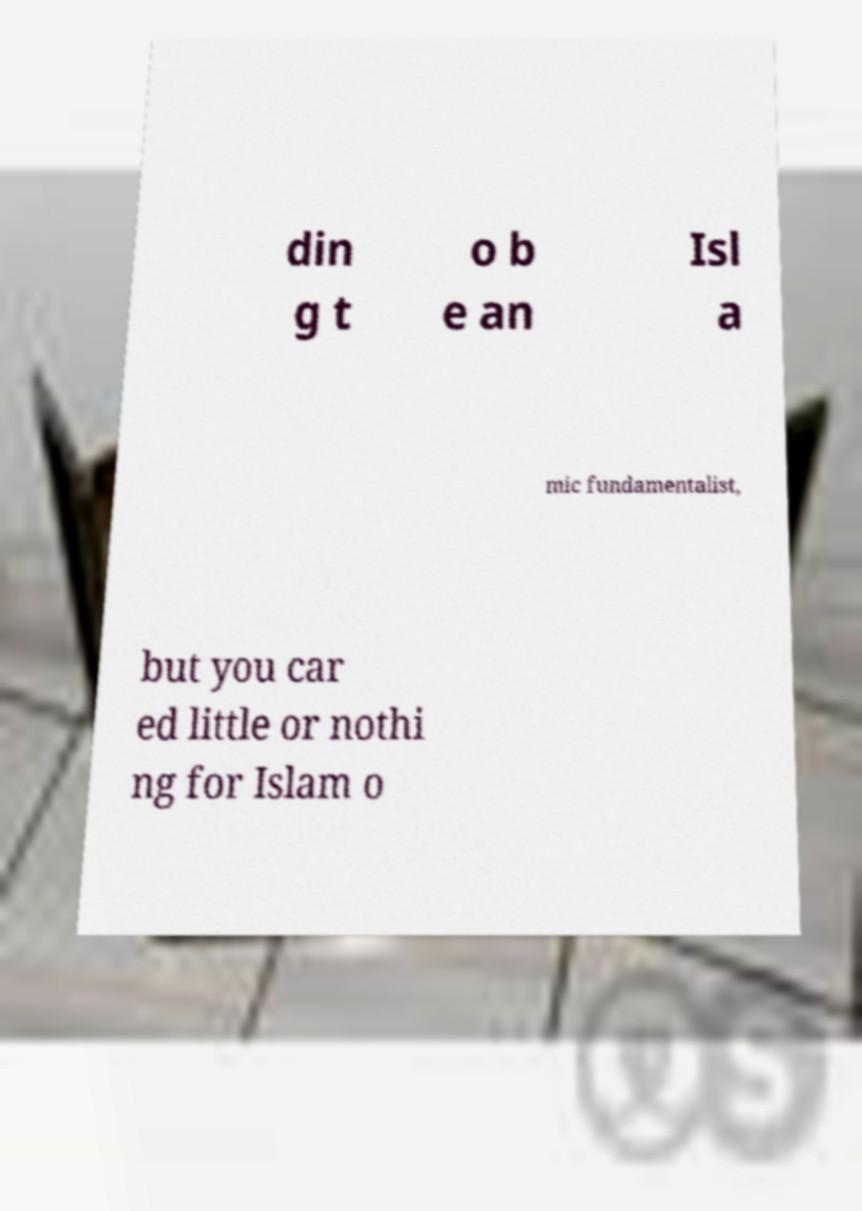I need the written content from this picture converted into text. Can you do that? din g t o b e an Isl a mic fundamentalist, but you car ed little or nothi ng for Islam o 